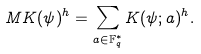<formula> <loc_0><loc_0><loc_500><loc_500>M K ( \psi ) ^ { h } = \sum _ { a \in \mathbb { F } _ { q } ^ { * } } K ( \psi ; a ) ^ { h } .</formula> 